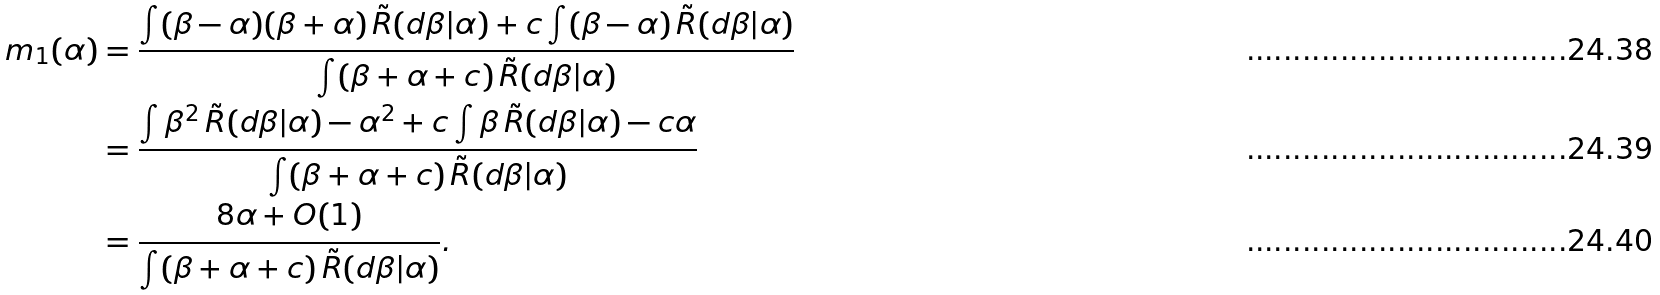Convert formula to latex. <formula><loc_0><loc_0><loc_500><loc_500>m _ { 1 } ( \alpha ) & = \frac { \int ( \beta - \alpha ) ( \beta + \alpha ) \, \tilde { R } ( d \beta | \alpha ) + c \int ( \beta - \alpha ) \, \tilde { R } ( d \beta | \alpha ) } { \int ( \beta + \alpha + c ) \, \tilde { R } ( d \beta | \alpha ) } \\ & = \frac { \int \beta ^ { 2 } \, \tilde { R } ( d \beta | \alpha ) - \alpha ^ { 2 } + c \int \beta \, \tilde { R } ( d \beta | \alpha ) - c \alpha } { \int ( \beta + \alpha + c ) \, \tilde { R } ( d \beta | \alpha ) } \\ & = \frac { 8 \alpha + O ( 1 ) } { \int ( \beta + \alpha + c ) \, \tilde { R } ( d \beta | \alpha ) } .</formula> 